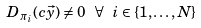Convert formula to latex. <formula><loc_0><loc_0><loc_500><loc_500>D _ { \pi _ { i } } ( c \vec { y } ) \neq 0 \text { } \forall \text { } i \in \{ 1 , \dots , N \}</formula> 